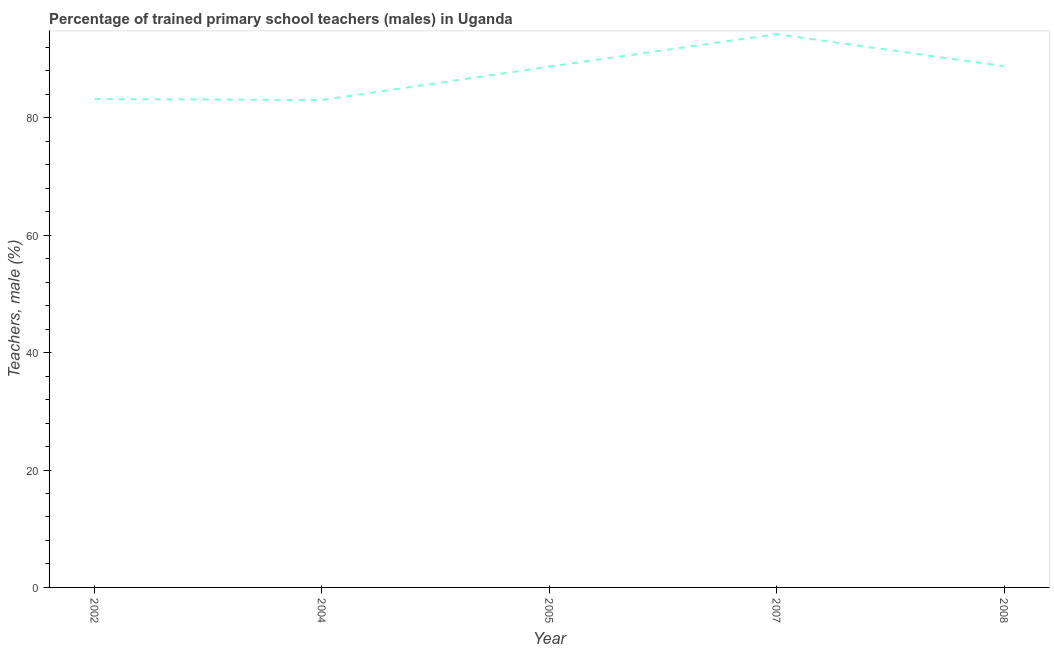What is the percentage of trained male teachers in 2007?
Your answer should be compact. 94.28. Across all years, what is the maximum percentage of trained male teachers?
Your response must be concise. 94.28. Across all years, what is the minimum percentage of trained male teachers?
Provide a short and direct response. 83.05. In which year was the percentage of trained male teachers maximum?
Provide a succinct answer. 2007. In which year was the percentage of trained male teachers minimum?
Your response must be concise. 2004. What is the sum of the percentage of trained male teachers?
Give a very brief answer. 438.08. What is the difference between the percentage of trained male teachers in 2007 and 2008?
Offer a terse response. 5.47. What is the average percentage of trained male teachers per year?
Offer a very short reply. 87.62. What is the median percentage of trained male teachers?
Your answer should be very brief. 88.73. In how many years, is the percentage of trained male teachers greater than 12 %?
Offer a terse response. 5. Do a majority of the years between 2002 and 2008 (inclusive) have percentage of trained male teachers greater than 32 %?
Offer a very short reply. Yes. What is the ratio of the percentage of trained male teachers in 2005 to that in 2007?
Your answer should be compact. 0.94. What is the difference between the highest and the second highest percentage of trained male teachers?
Ensure brevity in your answer.  5.47. What is the difference between the highest and the lowest percentage of trained male teachers?
Give a very brief answer. 11.23. In how many years, is the percentage of trained male teachers greater than the average percentage of trained male teachers taken over all years?
Offer a terse response. 3. Does the percentage of trained male teachers monotonically increase over the years?
Your response must be concise. No. How many lines are there?
Give a very brief answer. 1. Are the values on the major ticks of Y-axis written in scientific E-notation?
Your answer should be very brief. No. What is the title of the graph?
Make the answer very short. Percentage of trained primary school teachers (males) in Uganda. What is the label or title of the X-axis?
Offer a very short reply. Year. What is the label or title of the Y-axis?
Your response must be concise. Teachers, male (%). What is the Teachers, male (%) in 2002?
Provide a succinct answer. 83.21. What is the Teachers, male (%) of 2004?
Provide a succinct answer. 83.05. What is the Teachers, male (%) of 2005?
Make the answer very short. 88.73. What is the Teachers, male (%) of 2007?
Offer a terse response. 94.28. What is the Teachers, male (%) of 2008?
Keep it short and to the point. 88.81. What is the difference between the Teachers, male (%) in 2002 and 2004?
Offer a very short reply. 0.17. What is the difference between the Teachers, male (%) in 2002 and 2005?
Offer a terse response. -5.52. What is the difference between the Teachers, male (%) in 2002 and 2007?
Keep it short and to the point. -11.06. What is the difference between the Teachers, male (%) in 2002 and 2008?
Provide a short and direct response. -5.59. What is the difference between the Teachers, male (%) in 2004 and 2005?
Your response must be concise. -5.69. What is the difference between the Teachers, male (%) in 2004 and 2007?
Ensure brevity in your answer.  -11.23. What is the difference between the Teachers, male (%) in 2004 and 2008?
Make the answer very short. -5.76. What is the difference between the Teachers, male (%) in 2005 and 2007?
Provide a succinct answer. -5.54. What is the difference between the Teachers, male (%) in 2005 and 2008?
Ensure brevity in your answer.  -0.07. What is the difference between the Teachers, male (%) in 2007 and 2008?
Your answer should be compact. 5.47. What is the ratio of the Teachers, male (%) in 2002 to that in 2004?
Offer a very short reply. 1. What is the ratio of the Teachers, male (%) in 2002 to that in 2005?
Ensure brevity in your answer.  0.94. What is the ratio of the Teachers, male (%) in 2002 to that in 2007?
Ensure brevity in your answer.  0.88. What is the ratio of the Teachers, male (%) in 2002 to that in 2008?
Your answer should be compact. 0.94. What is the ratio of the Teachers, male (%) in 2004 to that in 2005?
Ensure brevity in your answer.  0.94. What is the ratio of the Teachers, male (%) in 2004 to that in 2007?
Offer a terse response. 0.88. What is the ratio of the Teachers, male (%) in 2004 to that in 2008?
Provide a short and direct response. 0.94. What is the ratio of the Teachers, male (%) in 2005 to that in 2007?
Keep it short and to the point. 0.94. What is the ratio of the Teachers, male (%) in 2007 to that in 2008?
Your answer should be compact. 1.06. 